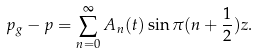<formula> <loc_0><loc_0><loc_500><loc_500>p _ { g } - p = \sum _ { n = 0 } ^ { \infty } A _ { n } ( t ) \sin \pi ( n + \frac { 1 } { 2 } ) z .</formula> 